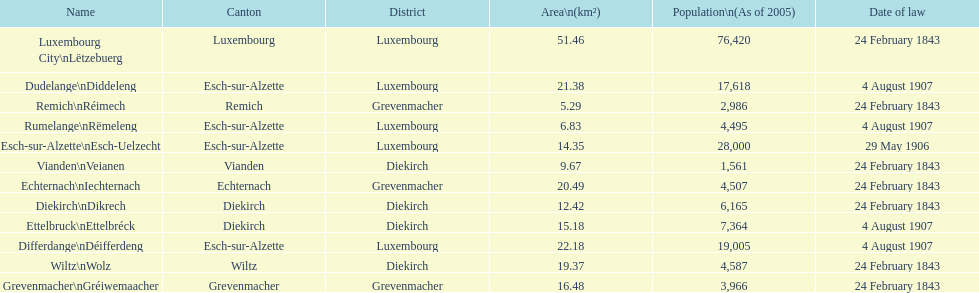I'm looking to parse the entire table for insights. Could you assist me with that? {'header': ['Name', 'Canton', 'District', 'Area\\n(km²)', 'Population\\n(As of 2005)', 'Date of law'], 'rows': [['Luxembourg City\\nLëtzebuerg', 'Luxembourg', 'Luxembourg', '51.46', '76,420', '24 February 1843'], ['Dudelange\\nDiddeleng', 'Esch-sur-Alzette', 'Luxembourg', '21.38', '17,618', '4 August 1907'], ['Remich\\nRéimech', 'Remich', 'Grevenmacher', '5.29', '2,986', '24 February 1843'], ['Rumelange\\nRëmeleng', 'Esch-sur-Alzette', 'Luxembourg', '6.83', '4,495', '4 August 1907'], ['Esch-sur-Alzette\\nEsch-Uelzecht', 'Esch-sur-Alzette', 'Luxembourg', '14.35', '28,000', '29 May 1906'], ['Vianden\\nVeianen', 'Vianden', 'Diekirch', '9.67', '1,561', '24 February 1843'], ['Echternach\\nIechternach', 'Echternach', 'Grevenmacher', '20.49', '4,507', '24 February 1843'], ['Diekirch\\nDikrech', 'Diekirch', 'Diekirch', '12.42', '6,165', '24 February 1843'], ['Ettelbruck\\nEttelbréck', 'Diekirch', 'Diekirch', '15.18', '7,364', '4 August 1907'], ['Differdange\\nDéifferdeng', 'Esch-sur-Alzette', 'Luxembourg', '22.18', '19,005', '4 August 1907'], ['Wiltz\\nWolz', 'Wiltz', 'Diekirch', '19.37', '4,587', '24 February 1843'], ['Grevenmacher\\nGréiwemaacher', 'Grevenmacher', 'Grevenmacher', '16.48', '3,966', '24 February 1843']]} What canton is the most populated? Luxembourg. 